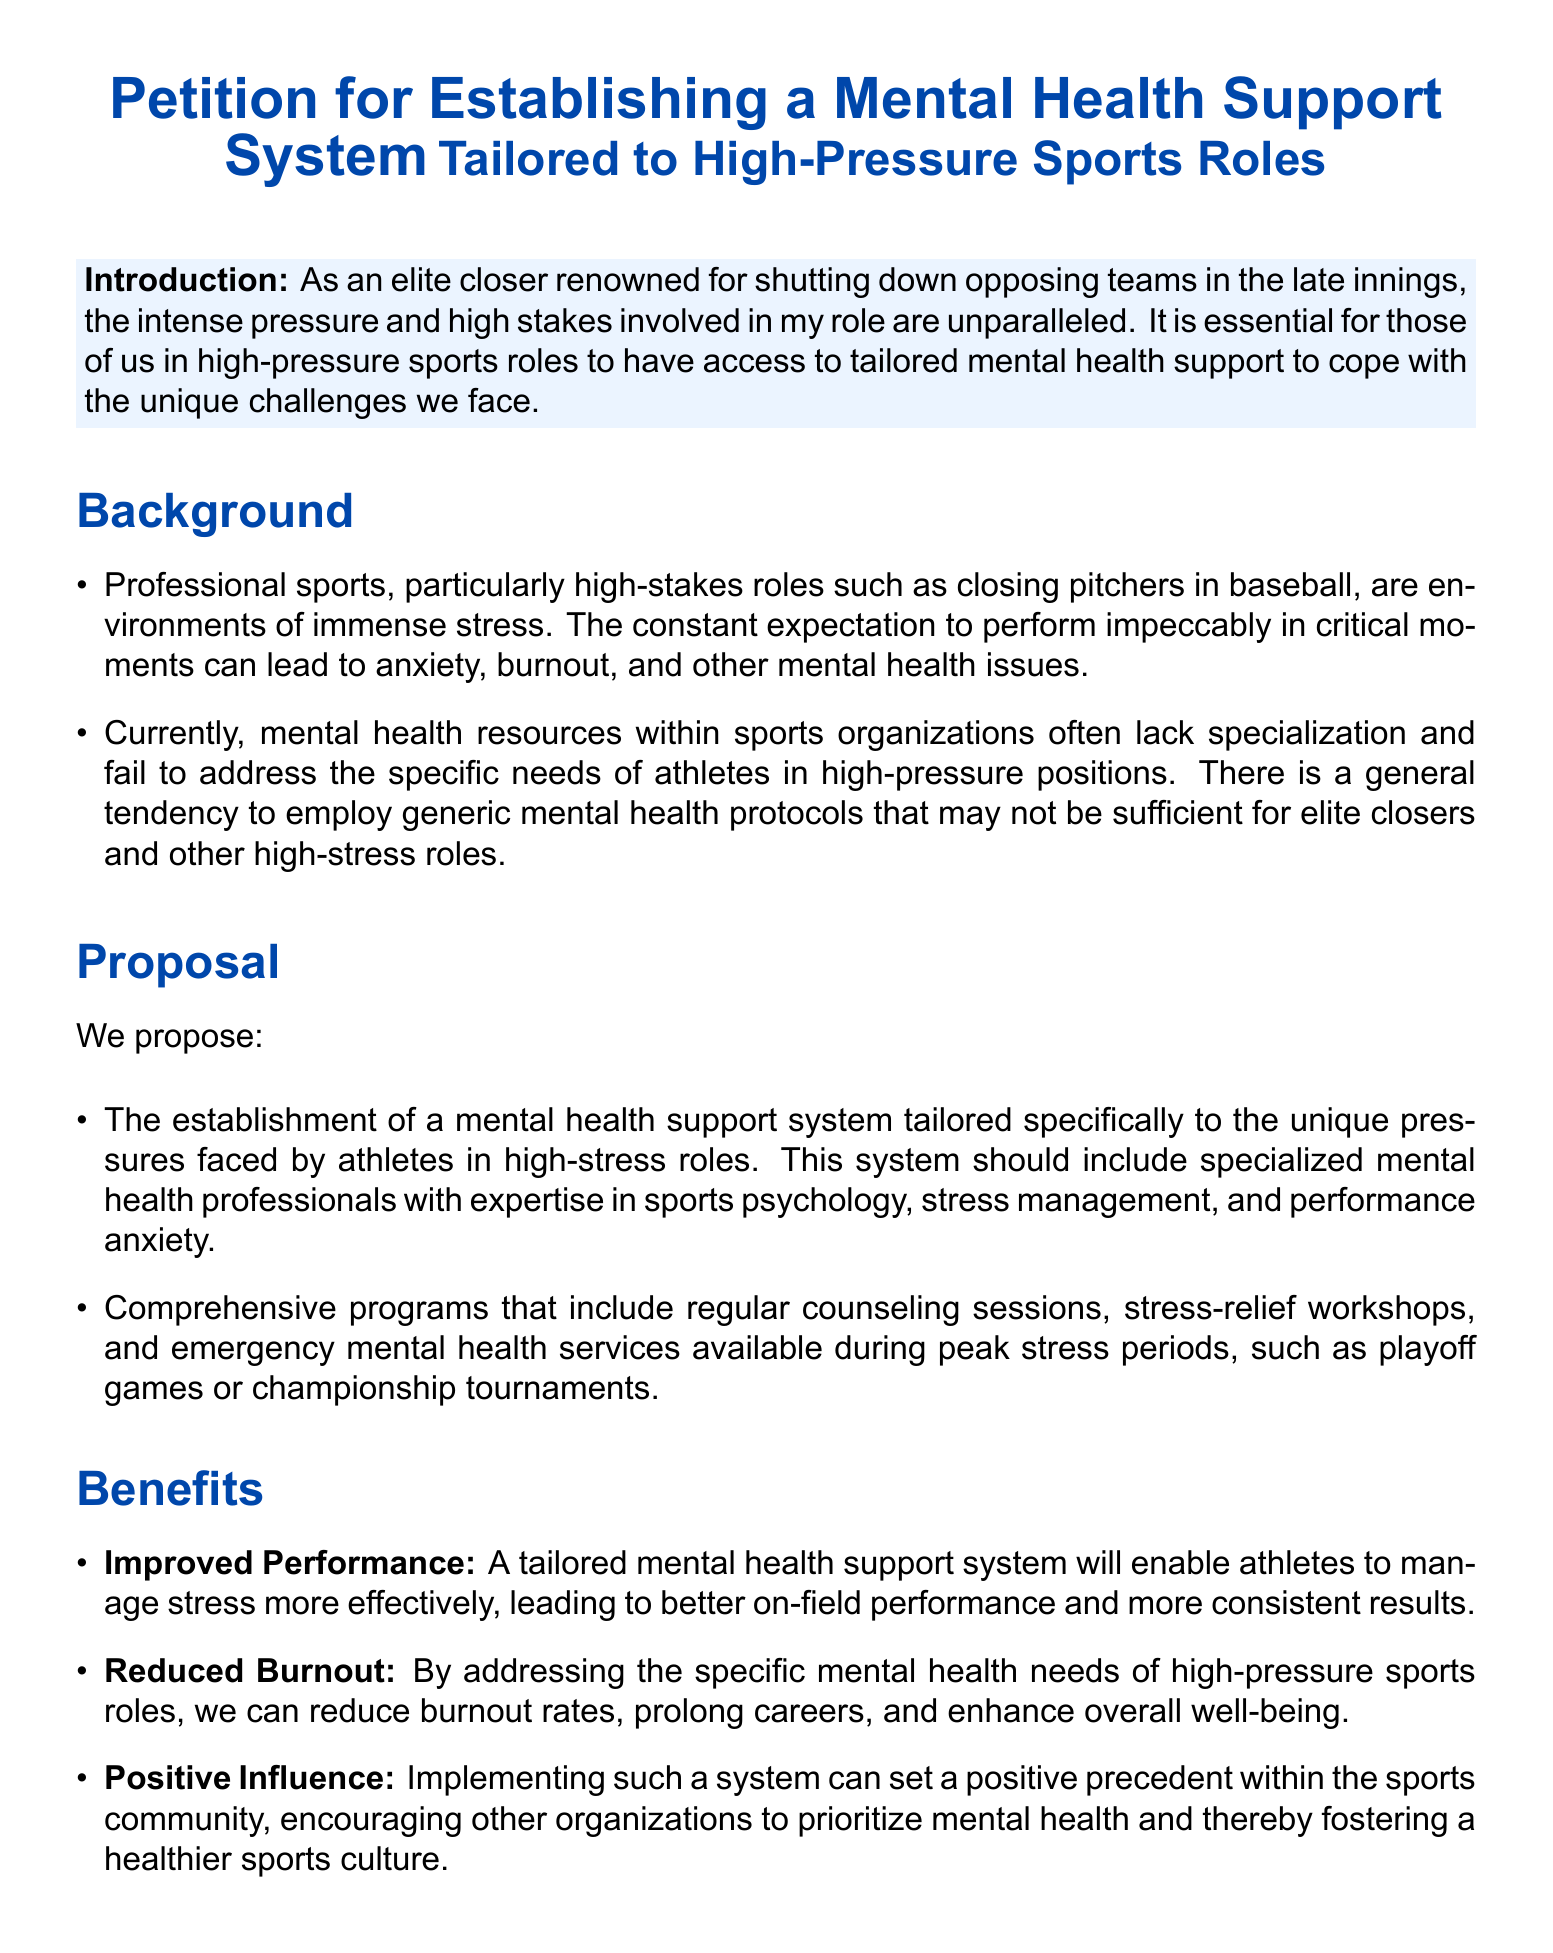What is the title of the petition? The title of the petition is mentioned at the beginning of the document.
Answer: Petition for Establishing a Mental Health Support System Tailored to High-Pressure Sports Roles Who is the petitioner identified as? The petitioner identifies themselves as an elite closer renowned for a specific in-game role.
Answer: elite closer What type of professionals are proposed in the mental health support system? The document specifies that the system should include professionals with particular expertise.
Answer: specialized mental health professionals What are two components of the proposed program? The document lists components that are part of the proposal for the mental health support system.
Answer: counseling sessions, stress-relief workshops What is one of the benefits mentioned regarding on-field performance? The document outlines benefits of implementing a tailored support system for athletes.
Answer: Improved Performance What is the call to action directed towards? The document includes a call to action aimed at specific groups or stakeholders.
Answer: sports organizations What is the intended effect of the proposed mental health system on burnout rates? The document addresses the impact that the support system aims to have on mental health challenges.
Answer: reduce burnout What does the document suggest can be set within the sports community? The document mentions the broader influence of the proposed support system on sports culture.
Answer: positive precedent 